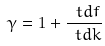<formula> <loc_0><loc_0><loc_500><loc_500>\gamma = 1 + \frac { \ t d f } { \ t d k }</formula> 